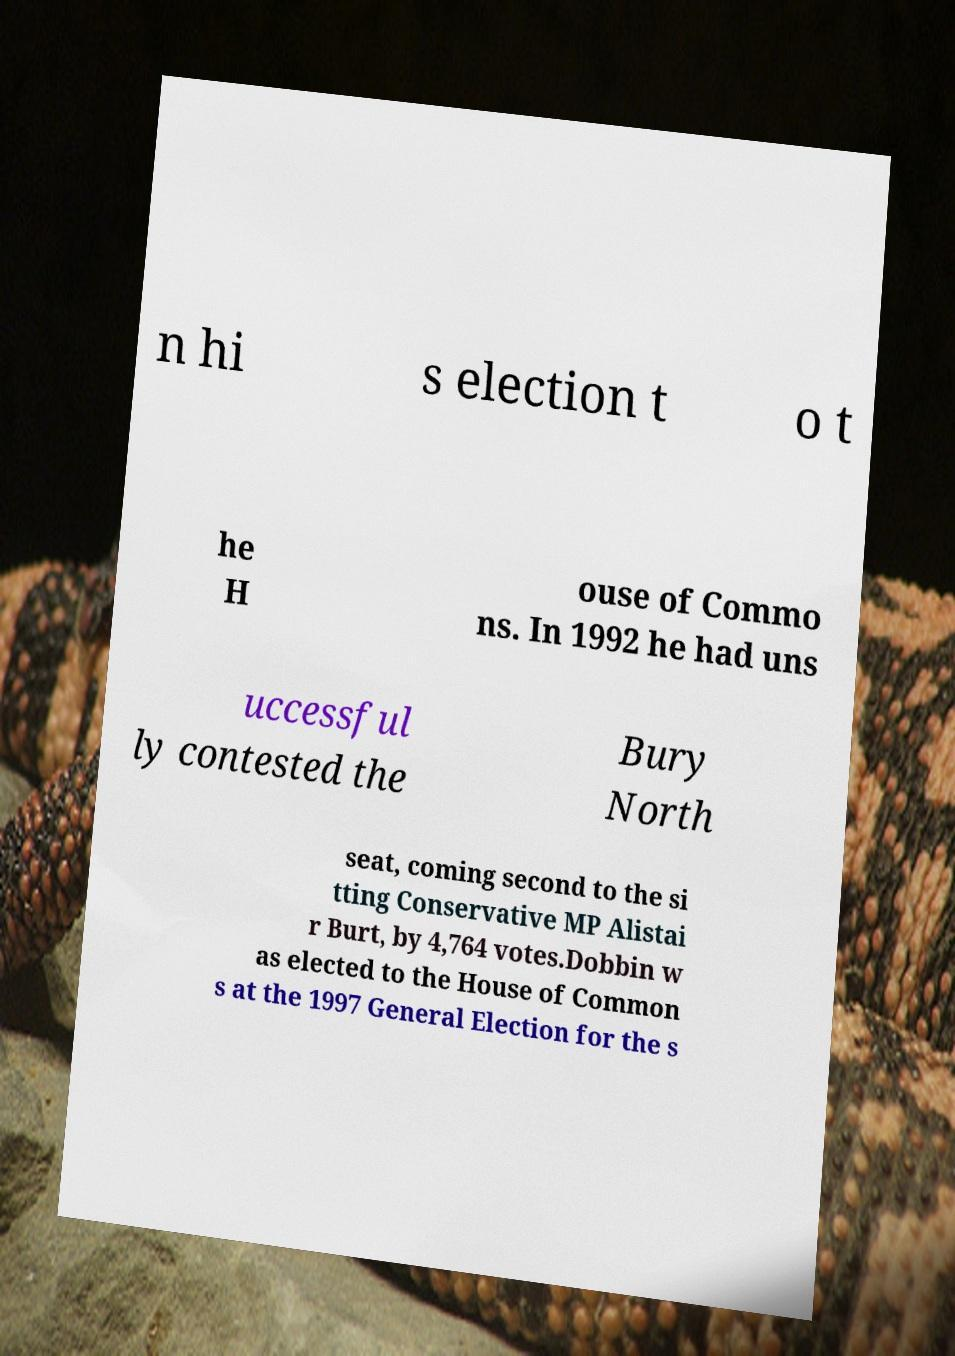I need the written content from this picture converted into text. Can you do that? n hi s election t o t he H ouse of Commo ns. In 1992 he had uns uccessful ly contested the Bury North seat, coming second to the si tting Conservative MP Alistai r Burt, by 4,764 votes.Dobbin w as elected to the House of Common s at the 1997 General Election for the s 